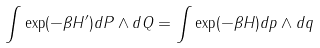Convert formula to latex. <formula><loc_0><loc_0><loc_500><loc_500>\int \exp ( - \beta H ^ { \prime } ) d P \wedge d Q = \int \exp ( - \beta H ) d p \wedge d q</formula> 